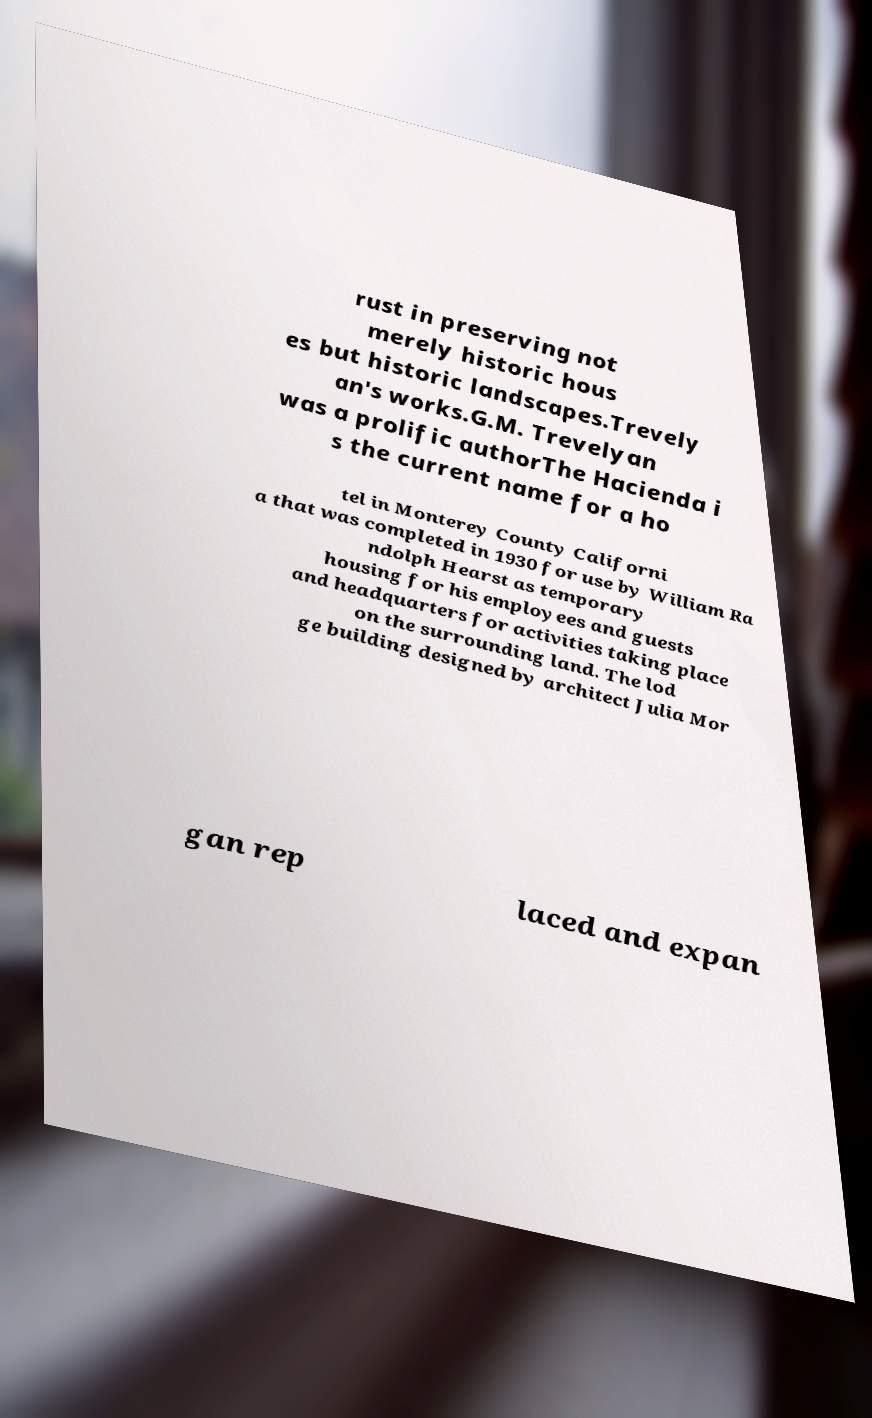What messages or text are displayed in this image? I need them in a readable, typed format. rust in preserving not merely historic hous es but historic landscapes.Trevely an's works.G.M. Trevelyan was a prolific authorThe Hacienda i s the current name for a ho tel in Monterey County Californi a that was completed in 1930 for use by William Ra ndolph Hearst as temporary housing for his employees and guests and headquarters for activities taking place on the surrounding land. The lod ge building designed by architect Julia Mor gan rep laced and expan 